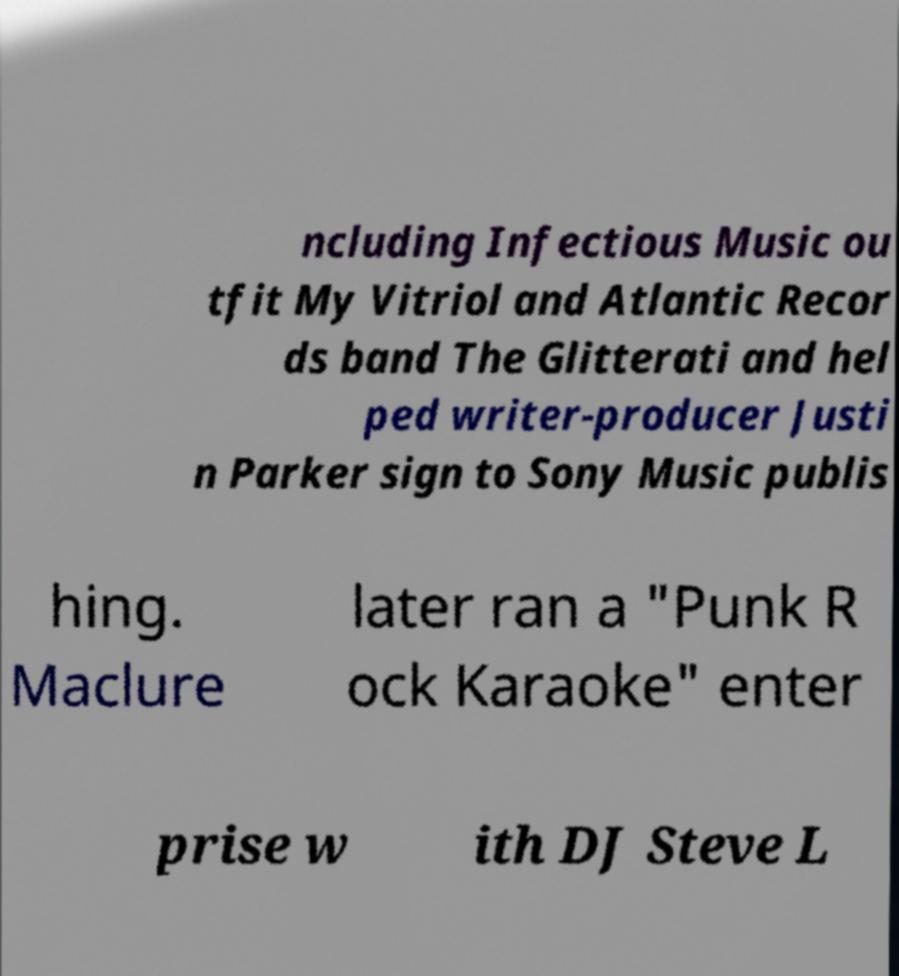Could you assist in decoding the text presented in this image and type it out clearly? ncluding Infectious Music ou tfit My Vitriol and Atlantic Recor ds band The Glitterati and hel ped writer-producer Justi n Parker sign to Sony Music publis hing. Maclure later ran a "Punk R ock Karaoke" enter prise w ith DJ Steve L 